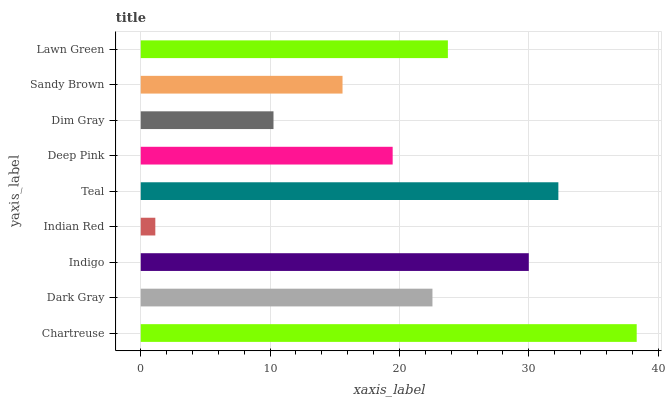Is Indian Red the minimum?
Answer yes or no. Yes. Is Chartreuse the maximum?
Answer yes or no. Yes. Is Dark Gray the minimum?
Answer yes or no. No. Is Dark Gray the maximum?
Answer yes or no. No. Is Chartreuse greater than Dark Gray?
Answer yes or no. Yes. Is Dark Gray less than Chartreuse?
Answer yes or no. Yes. Is Dark Gray greater than Chartreuse?
Answer yes or no. No. Is Chartreuse less than Dark Gray?
Answer yes or no. No. Is Dark Gray the high median?
Answer yes or no. Yes. Is Dark Gray the low median?
Answer yes or no. Yes. Is Dim Gray the high median?
Answer yes or no. No. Is Teal the low median?
Answer yes or no. No. 